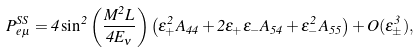Convert formula to latex. <formula><loc_0><loc_0><loc_500><loc_500>P _ { e \mu } ^ { S S } = 4 \sin ^ { 2 } \left ( \frac { M ^ { 2 } L } { 4 E _ { \nu } } \right ) \left ( \epsilon ^ { 2 } _ { + } A _ { 4 4 } + 2 \epsilon _ { + } \epsilon _ { - } A _ { 5 4 } + \epsilon _ { - } ^ { 2 } A _ { 5 5 } \right ) + O ( \epsilon _ { \pm } ^ { 3 } ) ,</formula> 